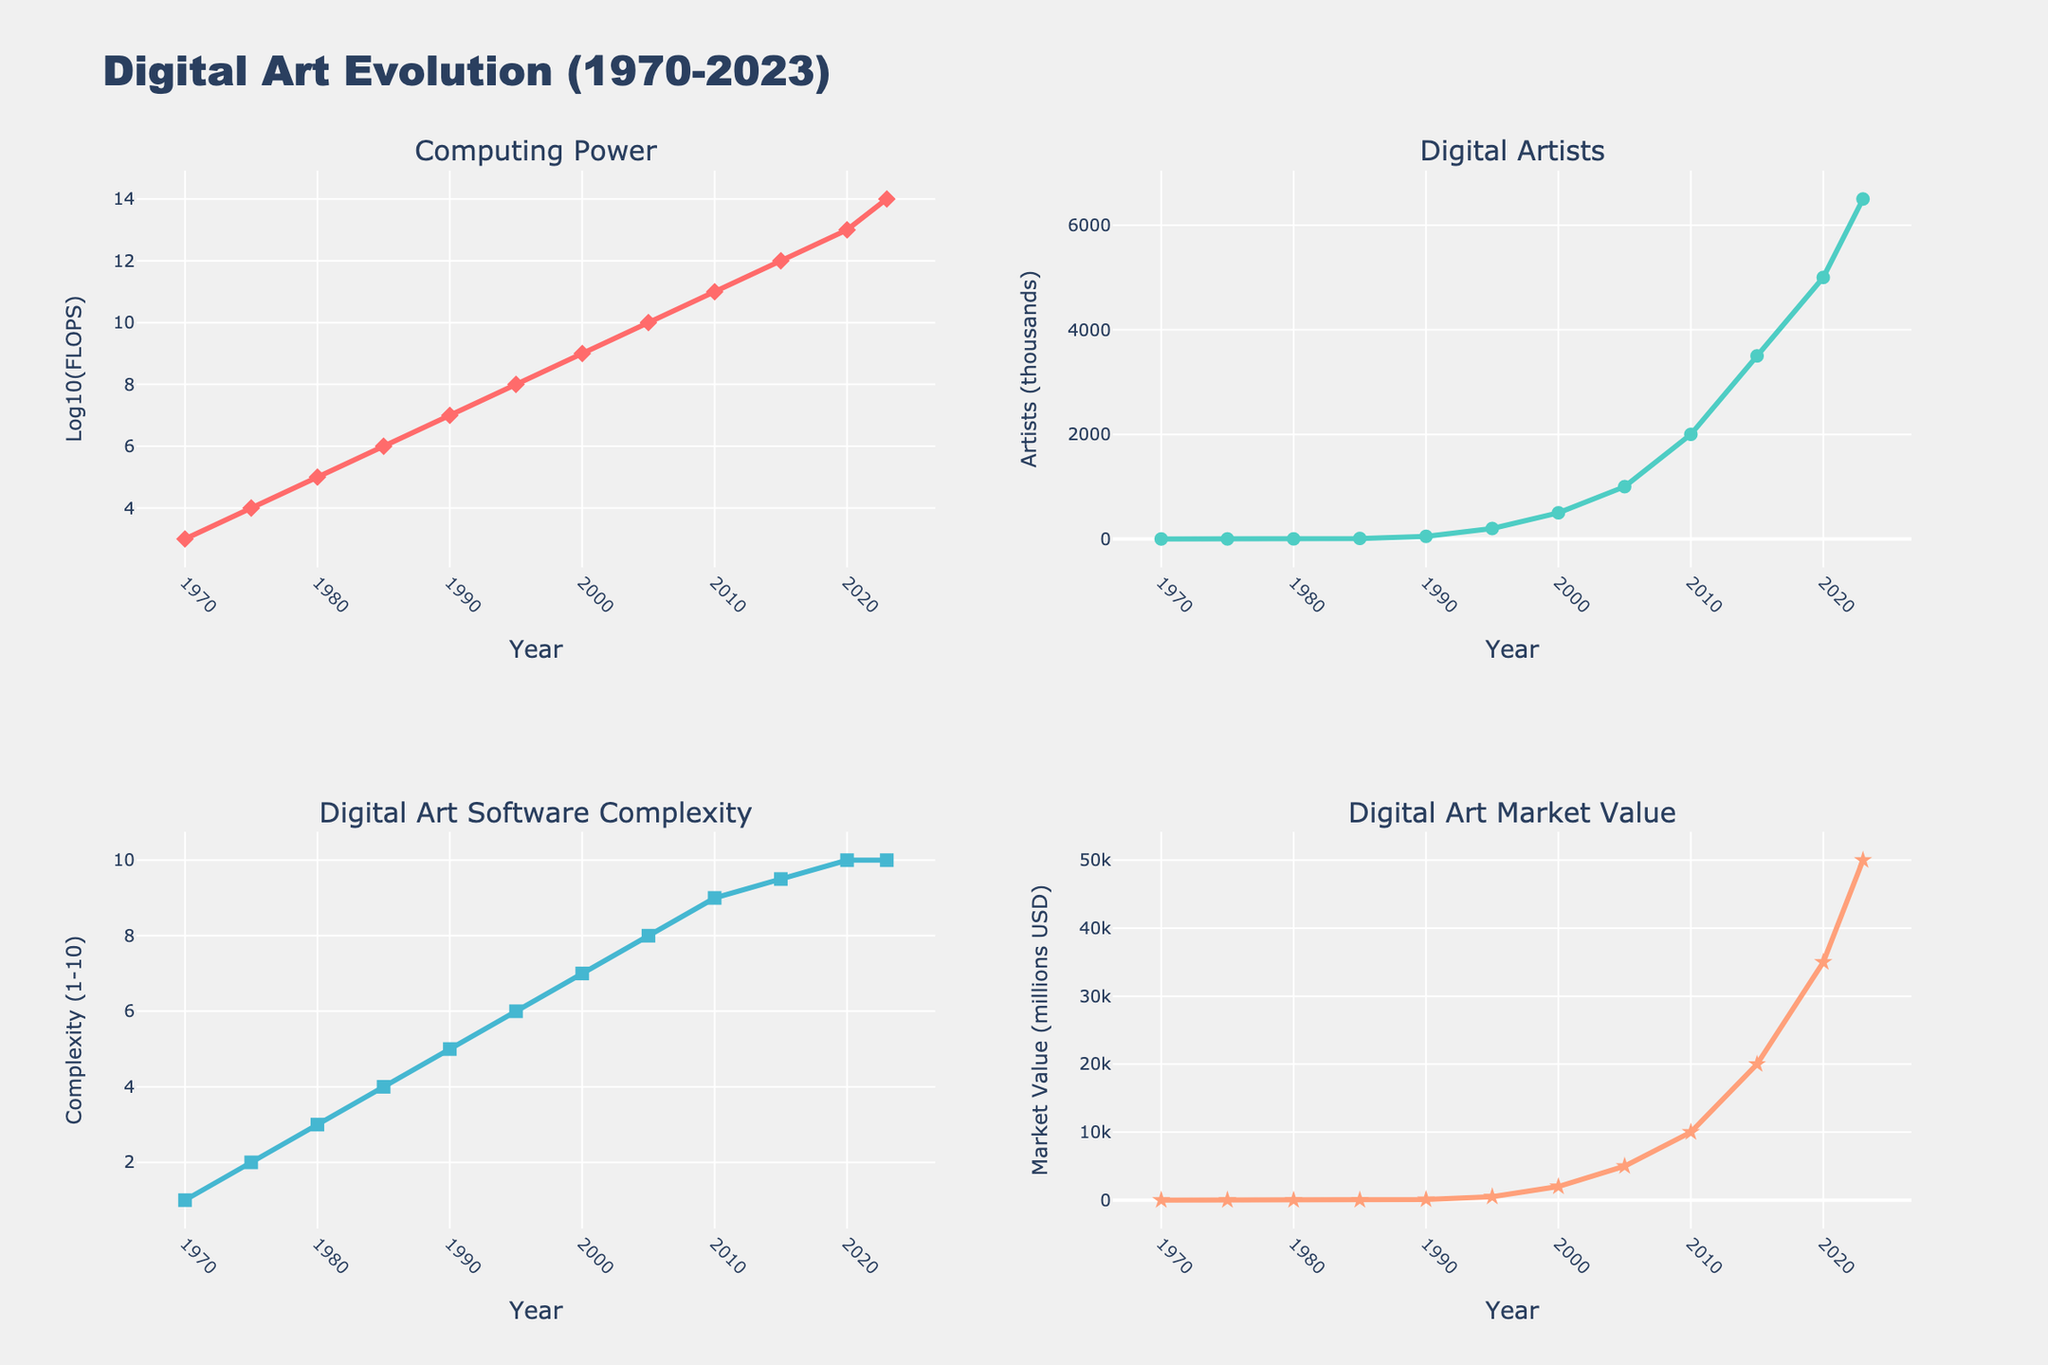What's the trend of computing power from 1970 to 2023? From 1970 to 2023, computing power, measured in FLOPS, has increased exponentially. In the figure, the line representing computing power rises steeply over the years, indicating a rapid advancement in computational efficiency and capability.
Answer: Exponential increase How has the number of digital artists changed over time? The number of digital artists has consistently increased over time. The plotted line for digital artists shows a steady climb from 0.1 thousand in 1970 to 6500 thousand in 2023.
Answer: Steady increase From 2000 to 2020, how did the market value of digital art change? The market value of digital art has increased significantly from 2000 to 2020. The figure shows the market value rising from 2000 million USD in 2000 to 35000 million USD in 2020.
Answer: Significant increase What is the relationship between digital art software complexity and market value from 2005 onward? From 2005 onward, both digital art software complexity and market value exhibit an increasing trend. Software complexity rises from 8 to 10, whereas the market value jumps from 5000 million USD to 50000 million USD, suggesting a possible correlation between software advancements and market growth.
Answer: Both increased Compare the rate of increase of digital artists from 1970 to 1980 and from 2015 to 2023. From 1970 to 1980, the number of digital artists rose from 0.1 thousand to 2 thousand (an increase of 1.9 thousand over 10 years). From 2015 to 2023, the number increased from 3500 thousand to 6500 thousand (an increase of 3000 thousand over 8 years), indicating a much faster increase in the latter period.
Answer: Faster increase from 2015 to 2023 What happens to the software complexity level after 2010? After 2010, the software complexity level increases slightly from 9 to 10 and then plateaus at the maximum value of 10, indicating that software complexity reaches a peak and stabilizes.
Answer: Plateaus at 10 Between 1990 and 2000, which factor saw the greatest absolute change: computing power, digital artists, or market value? In the figure, between 1990 and 2000, computing power increased from 10 million to 1 billion FLOPS (990 million increase); digital artists grew from 50 thousand to 500 thousand (450 thousand increase); market value increased from 100 million USD to 2000 million USD (1900 million increase). Thus, market value saw the greatest absolute change.
Answer: Market value How does the rate of increase in computing power compare to the rate of increase in market value from 1995 to 2005? Between 1995 and 2005, computing power increased from 100 million FLOPS to 10 billion FLOPS (a 100-fold increase), while the market value increased from 500 million USD to 5000 million USD (a 10-fold increase). Hence, the rate of increase in computing power was higher.
Answer: Higher for computing power When did the number of digital artists first exceed 1000 thousand? According to the figure, the number of digital artists exceeded 1000 thousand for the first time in 2005.
Answer: 2005 